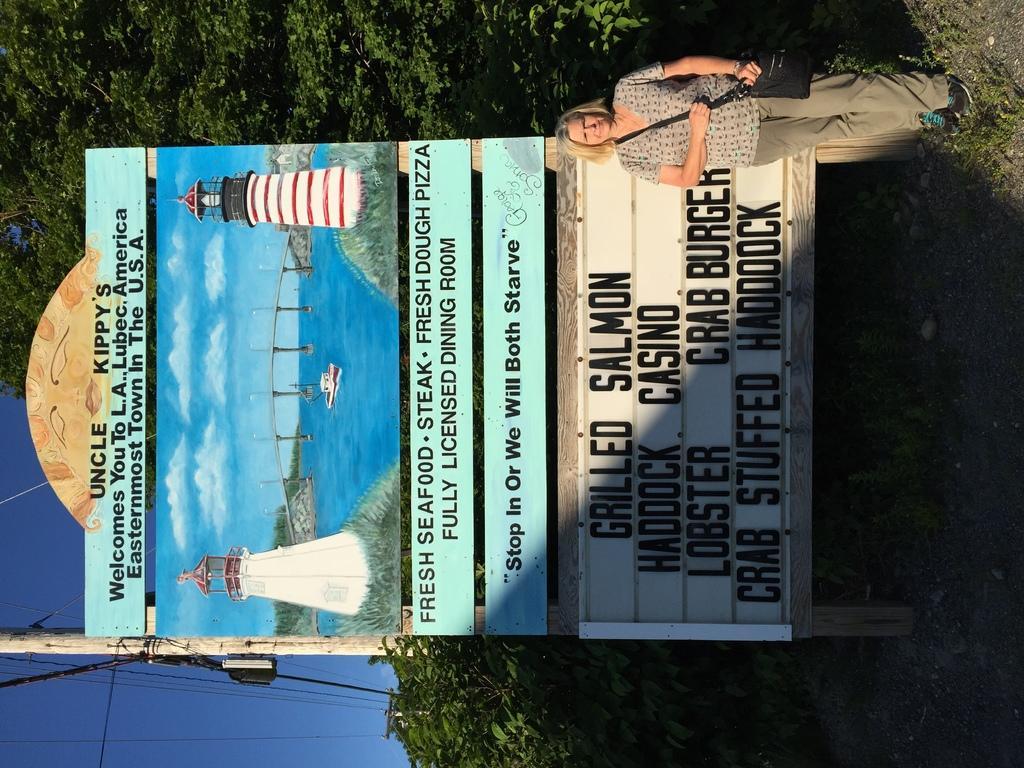Can you describe this image briefly? In this picture, we see the woman in grey T-shirt is standing. Behind her, we see a board in blue color with some text written on it. Beside that, we see an electric pole and wires. On the right side, we see the grass. There are trees in the background. In the left bottom of the picture, we see the sky, which is blue in color. 